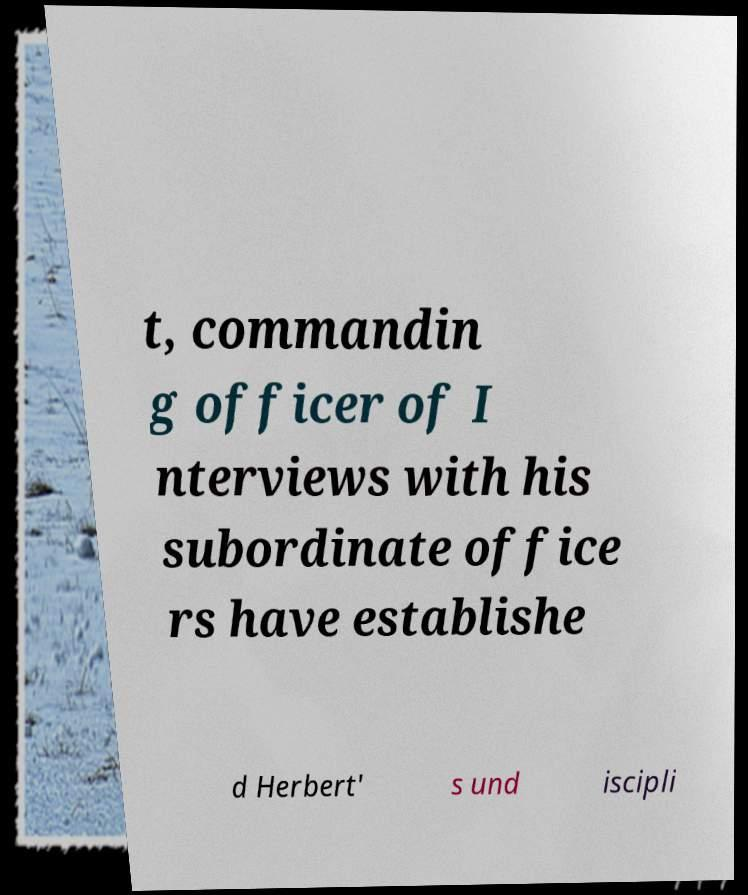Could you assist in decoding the text presented in this image and type it out clearly? t, commandin g officer of I nterviews with his subordinate office rs have establishe d Herbert' s und iscipli 